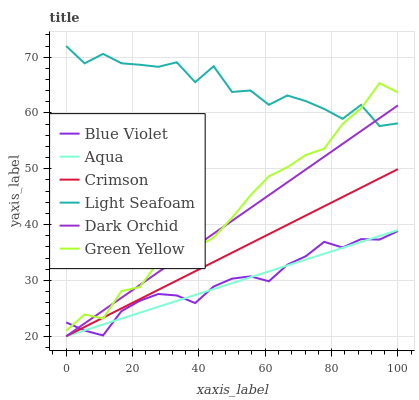Does Aqua have the minimum area under the curve?
Answer yes or no. Yes. Does Light Seafoam have the maximum area under the curve?
Answer yes or no. Yes. Does Dark Orchid have the minimum area under the curve?
Answer yes or no. No. Does Dark Orchid have the maximum area under the curve?
Answer yes or no. No. Is Aqua the smoothest?
Answer yes or no. Yes. Is Light Seafoam the roughest?
Answer yes or no. Yes. Is Dark Orchid the smoothest?
Answer yes or no. No. Is Dark Orchid the roughest?
Answer yes or no. No. Does Green Yellow have the lowest value?
Answer yes or no. No. Does Light Seafoam have the highest value?
Answer yes or no. Yes. Does Aqua have the highest value?
Answer yes or no. No. Is Aqua less than Light Seafoam?
Answer yes or no. Yes. Is Green Yellow greater than Aqua?
Answer yes or no. Yes. Does Aqua intersect Light Seafoam?
Answer yes or no. No. 